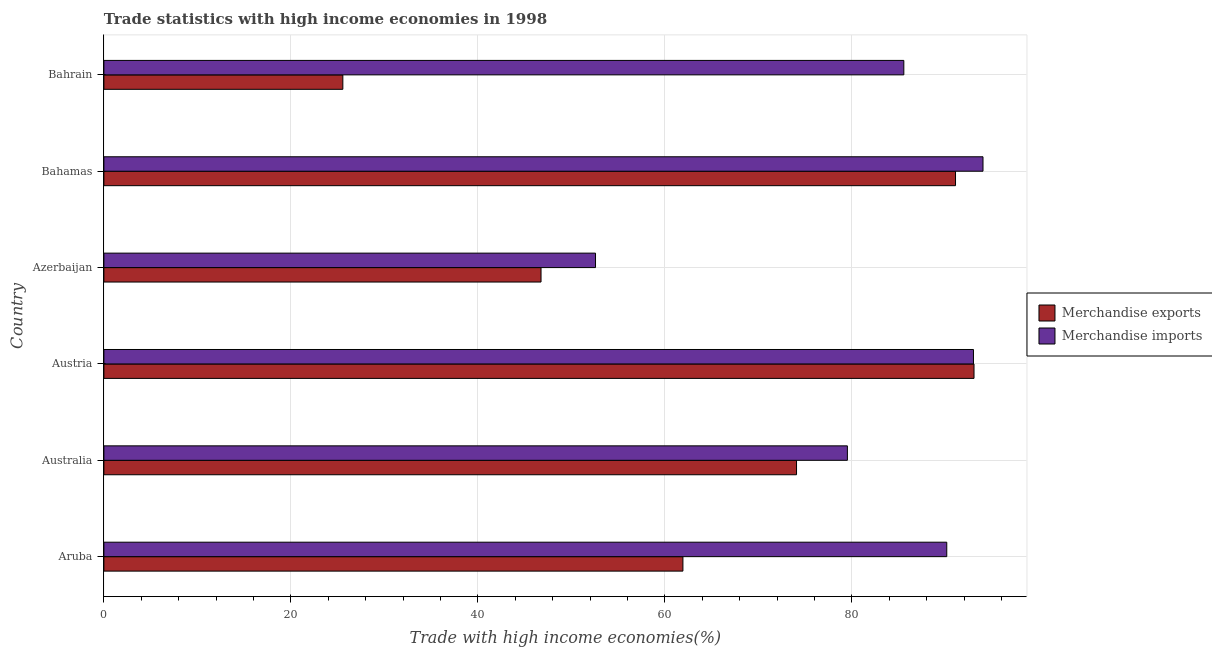How many bars are there on the 5th tick from the top?
Your answer should be compact. 2. What is the label of the 1st group of bars from the top?
Ensure brevity in your answer.  Bahrain. What is the merchandise imports in Bahrain?
Your answer should be compact. 85.55. Across all countries, what is the maximum merchandise imports?
Make the answer very short. 94.01. Across all countries, what is the minimum merchandise exports?
Provide a short and direct response. 25.55. In which country was the merchandise imports minimum?
Give a very brief answer. Azerbaijan. What is the total merchandise imports in the graph?
Your answer should be very brief. 494.77. What is the difference between the merchandise exports in Bahamas and that in Bahrain?
Your answer should be very brief. 65.52. What is the difference between the merchandise imports in Austria and the merchandise exports in Azerbaijan?
Make the answer very short. 46.25. What is the average merchandise imports per country?
Ensure brevity in your answer.  82.46. What is the difference between the merchandise imports and merchandise exports in Aruba?
Your response must be concise. 28.21. In how many countries, is the merchandise exports greater than 28 %?
Your answer should be very brief. 5. What is the ratio of the merchandise exports in Australia to that in Bahamas?
Make the answer very short. 0.81. Is the merchandise exports in Australia less than that in Azerbaijan?
Provide a succinct answer. No. Is the difference between the merchandise imports in Aruba and Bahamas greater than the difference between the merchandise exports in Aruba and Bahamas?
Provide a short and direct response. Yes. What is the difference between the highest and the second highest merchandise imports?
Keep it short and to the point. 1.02. What is the difference between the highest and the lowest merchandise imports?
Offer a very short reply. 41.44. What does the 1st bar from the top in Aruba represents?
Offer a terse response. Merchandise imports. How many bars are there?
Provide a short and direct response. 12. Are all the bars in the graph horizontal?
Your response must be concise. Yes. What is the difference between two consecutive major ticks on the X-axis?
Provide a short and direct response. 20. Where does the legend appear in the graph?
Provide a succinct answer. Center right. How many legend labels are there?
Make the answer very short. 2. What is the title of the graph?
Your answer should be compact. Trade statistics with high income economies in 1998. What is the label or title of the X-axis?
Ensure brevity in your answer.  Trade with high income economies(%). What is the Trade with high income economies(%) in Merchandise exports in Aruba?
Your response must be concise. 61.92. What is the Trade with high income economies(%) in Merchandise imports in Aruba?
Provide a succinct answer. 90.14. What is the Trade with high income economies(%) in Merchandise exports in Australia?
Your response must be concise. 74.07. What is the Trade with high income economies(%) in Merchandise imports in Australia?
Give a very brief answer. 79.51. What is the Trade with high income economies(%) in Merchandise exports in Austria?
Provide a succinct answer. 93.05. What is the Trade with high income economies(%) in Merchandise imports in Austria?
Give a very brief answer. 92.99. What is the Trade with high income economies(%) in Merchandise exports in Azerbaijan?
Provide a succinct answer. 46.75. What is the Trade with high income economies(%) of Merchandise imports in Azerbaijan?
Your response must be concise. 52.57. What is the Trade with high income economies(%) in Merchandise exports in Bahamas?
Your response must be concise. 91.07. What is the Trade with high income economies(%) in Merchandise imports in Bahamas?
Give a very brief answer. 94.01. What is the Trade with high income economies(%) in Merchandise exports in Bahrain?
Your answer should be compact. 25.55. What is the Trade with high income economies(%) in Merchandise imports in Bahrain?
Keep it short and to the point. 85.55. Across all countries, what is the maximum Trade with high income economies(%) in Merchandise exports?
Keep it short and to the point. 93.05. Across all countries, what is the maximum Trade with high income economies(%) in Merchandise imports?
Provide a short and direct response. 94.01. Across all countries, what is the minimum Trade with high income economies(%) in Merchandise exports?
Offer a terse response. 25.55. Across all countries, what is the minimum Trade with high income economies(%) of Merchandise imports?
Your answer should be very brief. 52.57. What is the total Trade with high income economies(%) in Merchandise exports in the graph?
Provide a short and direct response. 392.42. What is the total Trade with high income economies(%) of Merchandise imports in the graph?
Provide a short and direct response. 494.77. What is the difference between the Trade with high income economies(%) in Merchandise exports in Aruba and that in Australia?
Provide a short and direct response. -12.15. What is the difference between the Trade with high income economies(%) of Merchandise imports in Aruba and that in Australia?
Your response must be concise. 10.63. What is the difference between the Trade with high income economies(%) of Merchandise exports in Aruba and that in Austria?
Your response must be concise. -31.13. What is the difference between the Trade with high income economies(%) of Merchandise imports in Aruba and that in Austria?
Your answer should be very brief. -2.86. What is the difference between the Trade with high income economies(%) of Merchandise exports in Aruba and that in Azerbaijan?
Give a very brief answer. 15.17. What is the difference between the Trade with high income economies(%) of Merchandise imports in Aruba and that in Azerbaijan?
Provide a short and direct response. 37.56. What is the difference between the Trade with high income economies(%) in Merchandise exports in Aruba and that in Bahamas?
Provide a succinct answer. -29.15. What is the difference between the Trade with high income economies(%) in Merchandise imports in Aruba and that in Bahamas?
Give a very brief answer. -3.88. What is the difference between the Trade with high income economies(%) of Merchandise exports in Aruba and that in Bahrain?
Your response must be concise. 36.37. What is the difference between the Trade with high income economies(%) of Merchandise imports in Aruba and that in Bahrain?
Your answer should be very brief. 4.59. What is the difference between the Trade with high income economies(%) in Merchandise exports in Australia and that in Austria?
Keep it short and to the point. -18.98. What is the difference between the Trade with high income economies(%) in Merchandise imports in Australia and that in Austria?
Your answer should be very brief. -13.48. What is the difference between the Trade with high income economies(%) of Merchandise exports in Australia and that in Azerbaijan?
Provide a succinct answer. 27.32. What is the difference between the Trade with high income economies(%) of Merchandise imports in Australia and that in Azerbaijan?
Give a very brief answer. 26.94. What is the difference between the Trade with high income economies(%) of Merchandise exports in Australia and that in Bahamas?
Provide a short and direct response. -17. What is the difference between the Trade with high income economies(%) in Merchandise imports in Australia and that in Bahamas?
Your answer should be very brief. -14.5. What is the difference between the Trade with high income economies(%) of Merchandise exports in Australia and that in Bahrain?
Make the answer very short. 48.52. What is the difference between the Trade with high income economies(%) in Merchandise imports in Australia and that in Bahrain?
Ensure brevity in your answer.  -6.04. What is the difference between the Trade with high income economies(%) in Merchandise exports in Austria and that in Azerbaijan?
Your response must be concise. 46.3. What is the difference between the Trade with high income economies(%) in Merchandise imports in Austria and that in Azerbaijan?
Give a very brief answer. 40.42. What is the difference between the Trade with high income economies(%) in Merchandise exports in Austria and that in Bahamas?
Keep it short and to the point. 1.98. What is the difference between the Trade with high income economies(%) in Merchandise imports in Austria and that in Bahamas?
Your answer should be very brief. -1.02. What is the difference between the Trade with high income economies(%) in Merchandise exports in Austria and that in Bahrain?
Ensure brevity in your answer.  67.5. What is the difference between the Trade with high income economies(%) of Merchandise imports in Austria and that in Bahrain?
Give a very brief answer. 7.45. What is the difference between the Trade with high income economies(%) in Merchandise exports in Azerbaijan and that in Bahamas?
Provide a succinct answer. -44.33. What is the difference between the Trade with high income economies(%) in Merchandise imports in Azerbaijan and that in Bahamas?
Provide a succinct answer. -41.44. What is the difference between the Trade with high income economies(%) in Merchandise exports in Azerbaijan and that in Bahrain?
Your answer should be very brief. 21.19. What is the difference between the Trade with high income economies(%) of Merchandise imports in Azerbaijan and that in Bahrain?
Provide a succinct answer. -32.97. What is the difference between the Trade with high income economies(%) in Merchandise exports in Bahamas and that in Bahrain?
Give a very brief answer. 65.52. What is the difference between the Trade with high income economies(%) in Merchandise imports in Bahamas and that in Bahrain?
Ensure brevity in your answer.  8.47. What is the difference between the Trade with high income economies(%) of Merchandise exports in Aruba and the Trade with high income economies(%) of Merchandise imports in Australia?
Your answer should be very brief. -17.59. What is the difference between the Trade with high income economies(%) in Merchandise exports in Aruba and the Trade with high income economies(%) in Merchandise imports in Austria?
Your answer should be compact. -31.07. What is the difference between the Trade with high income economies(%) in Merchandise exports in Aruba and the Trade with high income economies(%) in Merchandise imports in Azerbaijan?
Make the answer very short. 9.35. What is the difference between the Trade with high income economies(%) of Merchandise exports in Aruba and the Trade with high income economies(%) of Merchandise imports in Bahamas?
Ensure brevity in your answer.  -32.09. What is the difference between the Trade with high income economies(%) in Merchandise exports in Aruba and the Trade with high income economies(%) in Merchandise imports in Bahrain?
Offer a very short reply. -23.62. What is the difference between the Trade with high income economies(%) in Merchandise exports in Australia and the Trade with high income economies(%) in Merchandise imports in Austria?
Your response must be concise. -18.92. What is the difference between the Trade with high income economies(%) in Merchandise exports in Australia and the Trade with high income economies(%) in Merchandise imports in Azerbaijan?
Your answer should be very brief. 21.5. What is the difference between the Trade with high income economies(%) of Merchandise exports in Australia and the Trade with high income economies(%) of Merchandise imports in Bahamas?
Provide a succinct answer. -19.94. What is the difference between the Trade with high income economies(%) in Merchandise exports in Australia and the Trade with high income economies(%) in Merchandise imports in Bahrain?
Ensure brevity in your answer.  -11.47. What is the difference between the Trade with high income economies(%) in Merchandise exports in Austria and the Trade with high income economies(%) in Merchandise imports in Azerbaijan?
Give a very brief answer. 40.48. What is the difference between the Trade with high income economies(%) of Merchandise exports in Austria and the Trade with high income economies(%) of Merchandise imports in Bahamas?
Make the answer very short. -0.96. What is the difference between the Trade with high income economies(%) in Merchandise exports in Austria and the Trade with high income economies(%) in Merchandise imports in Bahrain?
Your response must be concise. 7.51. What is the difference between the Trade with high income economies(%) of Merchandise exports in Azerbaijan and the Trade with high income economies(%) of Merchandise imports in Bahamas?
Your answer should be compact. -47.27. What is the difference between the Trade with high income economies(%) in Merchandise exports in Azerbaijan and the Trade with high income economies(%) in Merchandise imports in Bahrain?
Your answer should be very brief. -38.8. What is the difference between the Trade with high income economies(%) in Merchandise exports in Bahamas and the Trade with high income economies(%) in Merchandise imports in Bahrain?
Make the answer very short. 5.53. What is the average Trade with high income economies(%) in Merchandise exports per country?
Keep it short and to the point. 65.4. What is the average Trade with high income economies(%) in Merchandise imports per country?
Ensure brevity in your answer.  82.46. What is the difference between the Trade with high income economies(%) in Merchandise exports and Trade with high income economies(%) in Merchandise imports in Aruba?
Ensure brevity in your answer.  -28.22. What is the difference between the Trade with high income economies(%) of Merchandise exports and Trade with high income economies(%) of Merchandise imports in Australia?
Ensure brevity in your answer.  -5.44. What is the difference between the Trade with high income economies(%) of Merchandise exports and Trade with high income economies(%) of Merchandise imports in Austria?
Provide a succinct answer. 0.06. What is the difference between the Trade with high income economies(%) of Merchandise exports and Trade with high income economies(%) of Merchandise imports in Azerbaijan?
Offer a very short reply. -5.83. What is the difference between the Trade with high income economies(%) in Merchandise exports and Trade with high income economies(%) in Merchandise imports in Bahamas?
Your answer should be very brief. -2.94. What is the difference between the Trade with high income economies(%) in Merchandise exports and Trade with high income economies(%) in Merchandise imports in Bahrain?
Keep it short and to the point. -59.99. What is the ratio of the Trade with high income economies(%) in Merchandise exports in Aruba to that in Australia?
Your answer should be very brief. 0.84. What is the ratio of the Trade with high income economies(%) in Merchandise imports in Aruba to that in Australia?
Your answer should be very brief. 1.13. What is the ratio of the Trade with high income economies(%) in Merchandise exports in Aruba to that in Austria?
Make the answer very short. 0.67. What is the ratio of the Trade with high income economies(%) of Merchandise imports in Aruba to that in Austria?
Your answer should be compact. 0.97. What is the ratio of the Trade with high income economies(%) of Merchandise exports in Aruba to that in Azerbaijan?
Your answer should be very brief. 1.32. What is the ratio of the Trade with high income economies(%) in Merchandise imports in Aruba to that in Azerbaijan?
Give a very brief answer. 1.71. What is the ratio of the Trade with high income economies(%) in Merchandise exports in Aruba to that in Bahamas?
Offer a terse response. 0.68. What is the ratio of the Trade with high income economies(%) in Merchandise imports in Aruba to that in Bahamas?
Offer a very short reply. 0.96. What is the ratio of the Trade with high income economies(%) of Merchandise exports in Aruba to that in Bahrain?
Keep it short and to the point. 2.42. What is the ratio of the Trade with high income economies(%) in Merchandise imports in Aruba to that in Bahrain?
Provide a short and direct response. 1.05. What is the ratio of the Trade with high income economies(%) in Merchandise exports in Australia to that in Austria?
Give a very brief answer. 0.8. What is the ratio of the Trade with high income economies(%) in Merchandise imports in Australia to that in Austria?
Offer a terse response. 0.85. What is the ratio of the Trade with high income economies(%) in Merchandise exports in Australia to that in Azerbaijan?
Your answer should be very brief. 1.58. What is the ratio of the Trade with high income economies(%) of Merchandise imports in Australia to that in Azerbaijan?
Keep it short and to the point. 1.51. What is the ratio of the Trade with high income economies(%) of Merchandise exports in Australia to that in Bahamas?
Provide a short and direct response. 0.81. What is the ratio of the Trade with high income economies(%) of Merchandise imports in Australia to that in Bahamas?
Offer a very short reply. 0.85. What is the ratio of the Trade with high income economies(%) of Merchandise exports in Australia to that in Bahrain?
Your answer should be very brief. 2.9. What is the ratio of the Trade with high income economies(%) of Merchandise imports in Australia to that in Bahrain?
Provide a short and direct response. 0.93. What is the ratio of the Trade with high income economies(%) in Merchandise exports in Austria to that in Azerbaijan?
Make the answer very short. 1.99. What is the ratio of the Trade with high income economies(%) of Merchandise imports in Austria to that in Azerbaijan?
Give a very brief answer. 1.77. What is the ratio of the Trade with high income economies(%) in Merchandise exports in Austria to that in Bahamas?
Give a very brief answer. 1.02. What is the ratio of the Trade with high income economies(%) of Merchandise exports in Austria to that in Bahrain?
Provide a succinct answer. 3.64. What is the ratio of the Trade with high income economies(%) of Merchandise imports in Austria to that in Bahrain?
Provide a succinct answer. 1.09. What is the ratio of the Trade with high income economies(%) of Merchandise exports in Azerbaijan to that in Bahamas?
Offer a very short reply. 0.51. What is the ratio of the Trade with high income economies(%) of Merchandise imports in Azerbaijan to that in Bahamas?
Your answer should be very brief. 0.56. What is the ratio of the Trade with high income economies(%) in Merchandise exports in Azerbaijan to that in Bahrain?
Provide a short and direct response. 1.83. What is the ratio of the Trade with high income economies(%) in Merchandise imports in Azerbaijan to that in Bahrain?
Your answer should be compact. 0.61. What is the ratio of the Trade with high income economies(%) of Merchandise exports in Bahamas to that in Bahrain?
Your answer should be very brief. 3.56. What is the ratio of the Trade with high income economies(%) of Merchandise imports in Bahamas to that in Bahrain?
Your answer should be very brief. 1.1. What is the difference between the highest and the second highest Trade with high income economies(%) of Merchandise exports?
Provide a succinct answer. 1.98. What is the difference between the highest and the second highest Trade with high income economies(%) of Merchandise imports?
Keep it short and to the point. 1.02. What is the difference between the highest and the lowest Trade with high income economies(%) in Merchandise exports?
Keep it short and to the point. 67.5. What is the difference between the highest and the lowest Trade with high income economies(%) of Merchandise imports?
Offer a terse response. 41.44. 